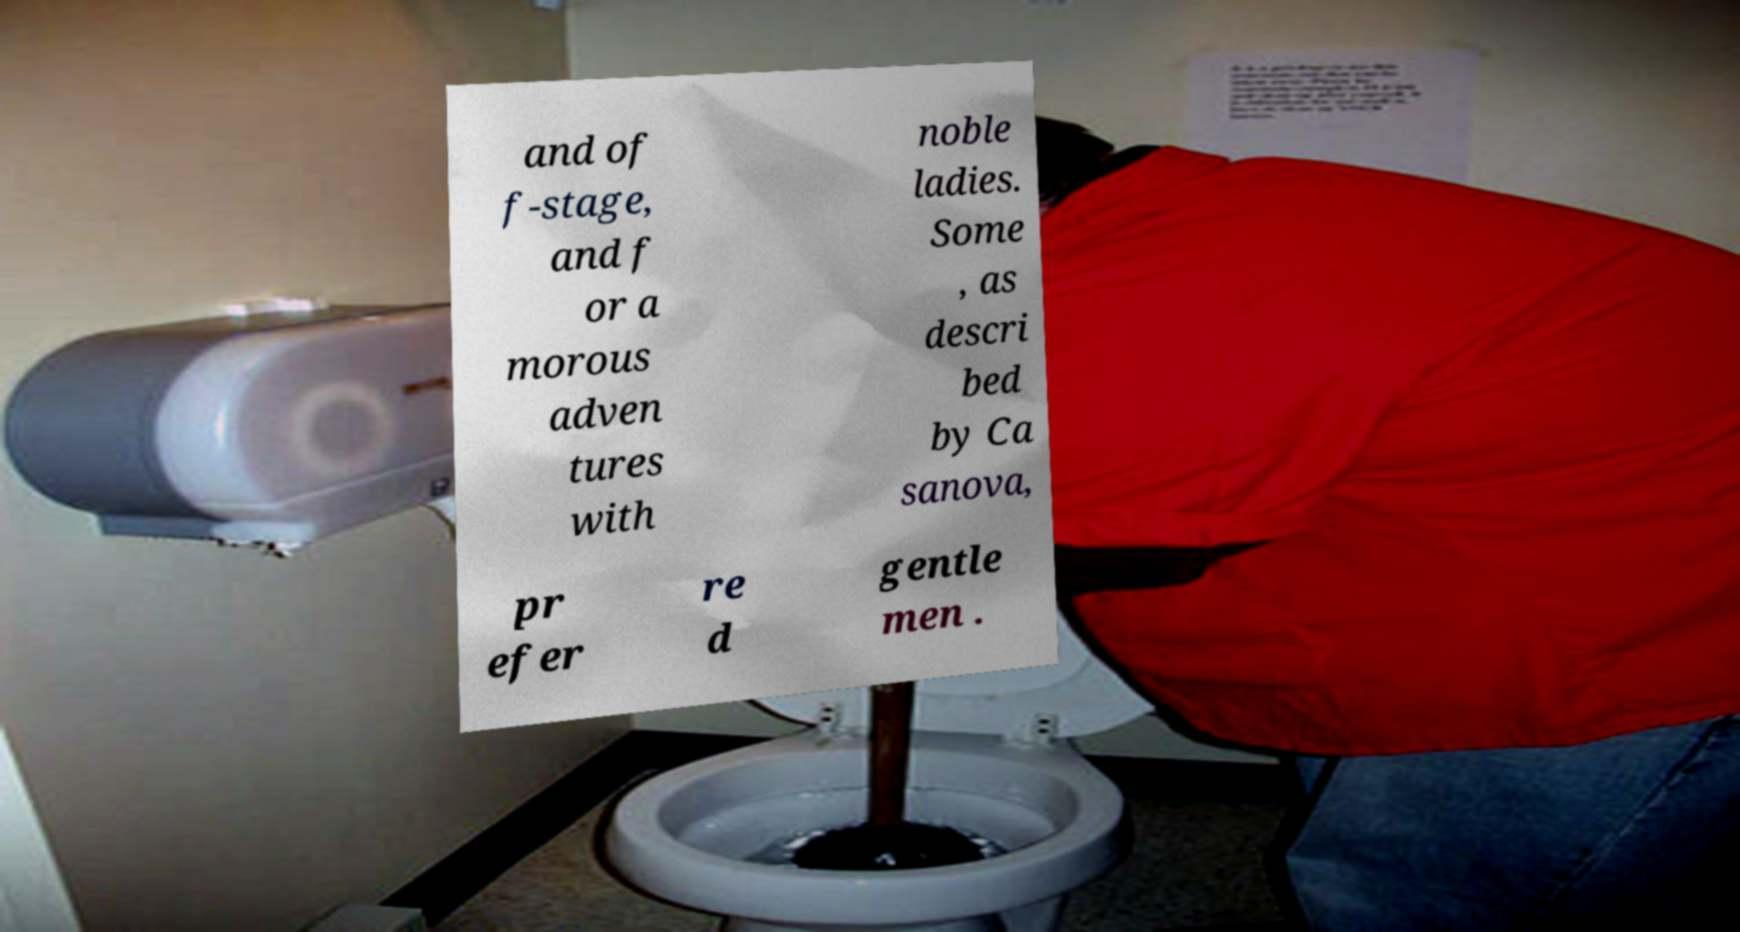I need the written content from this picture converted into text. Can you do that? and of f-stage, and f or a morous adven tures with noble ladies. Some , as descri bed by Ca sanova, pr efer re d gentle men . 